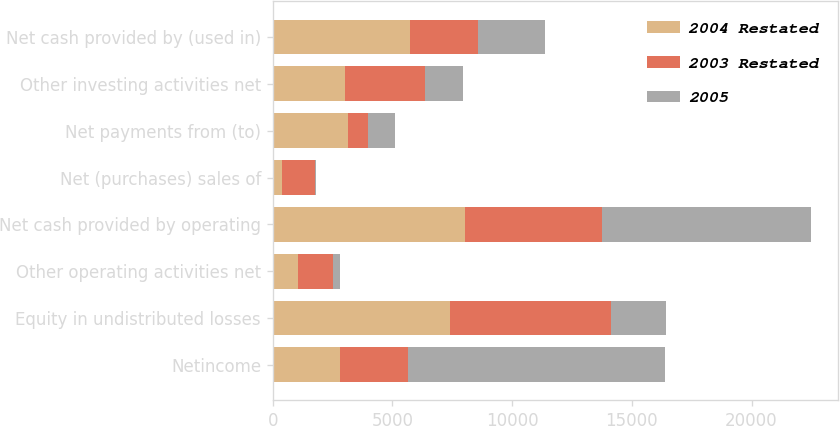Convert chart to OTSL. <chart><loc_0><loc_0><loc_500><loc_500><stacked_bar_chart><ecel><fcel>Netincome<fcel>Equity in undistributed losses<fcel>Other operating activities net<fcel>Net cash provided by operating<fcel>Net (purchases) sales of<fcel>Net payments from (to)<fcel>Other investing activities net<fcel>Net cash provided by (used in)<nl><fcel>2004 Restated<fcel>2819<fcel>7390<fcel>1035<fcel>8040<fcel>403<fcel>3145<fcel>3001<fcel>5743<nl><fcel>2003 Restated<fcel>2819<fcel>6739<fcel>1487<fcel>5721<fcel>1348<fcel>821<fcel>3348<fcel>2821<nl><fcel>2005<fcel>10762<fcel>2318<fcel>295<fcel>8739<fcel>59<fcel>1160<fcel>1598<fcel>2817<nl></chart> 